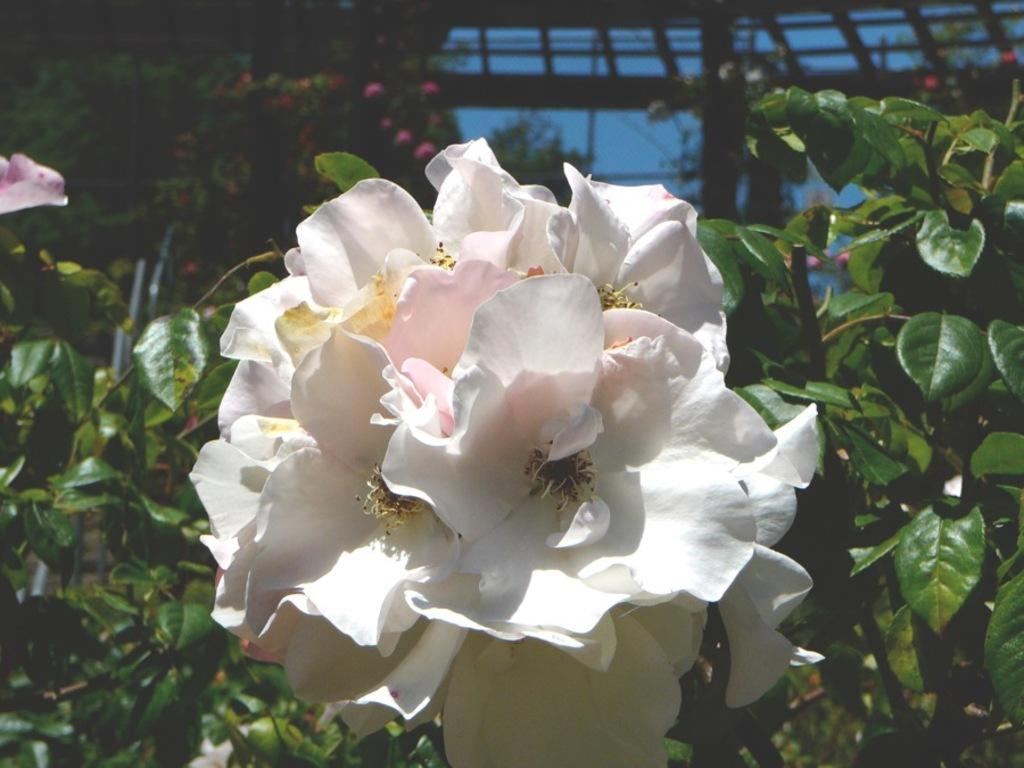What is the main subject in the center of the image? There are flowers in the center of the image. What type of vegetation surrounds the flowers? There is greenery around the area of the image. What structure can be seen at the top side of the image? There is a roof at the top side of the image. How many straws are placed on the roof in the image? There are no straws present in the image. What type of pig can be seen interacting with the flowers in the image? There is no pig present in the image; it only features flowers and greenery. 